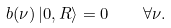Convert formula to latex. <formula><loc_0><loc_0><loc_500><loc_500>b ( \nu ) \left | 0 , R \right > = 0 \quad \forall \nu .</formula> 